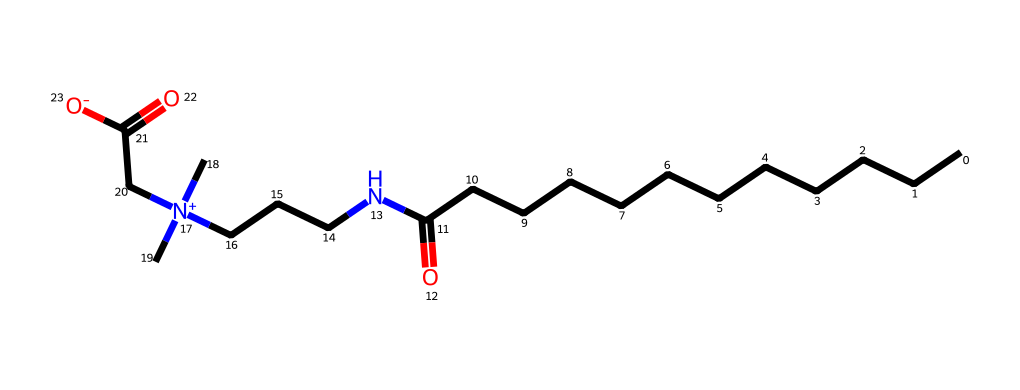What is the chemical name of this compound? The SMILES notation indicates a specific molecular structure, which corresponds to cocamidopropyl betaine, a well-known amphoteric surfactant.
Answer: cocamidopropyl betaine How many carbon atoms are present in this molecule? The SMILES shows a sequence of "C" symbols representing carbon atoms, and by counting, there are 14 carbon atoms in the main chain and additional terminal groups.
Answer: 14 What type of surfactant is cocamidopropyl betaine? The presence of both cationic and anionic groups in the structure classifies cocamidopropyl betaine as an amphoteric surfactant.
Answer: amphoteric How many nitrogen atoms are in cocamidopropyl betaine? The SMILES reveals two "N" symbols, indicating the presence of two nitrogen atoms in the molecule.
Answer: 2 What is the significance of the quaternary ammonium group in the structure? The quaternary ammonium group, indicated by [N+](C)(C), contributes to the surfactant's positive charge, enhancing its ability to interact with various substances, making it effective in personal care formulations.
Answer: positive charge How many oxygen atoms are present in the molecule? The molecule contains two oxygen atoms, as seen in the functional groups where O is listed in the SMILES. Counting these reveals two distinct oxygen contributions.
Answer: 2 What property does the long carbon chain provide to cocamidopropyl betaine? The long carbon chain contributes hydrophobic characteristics, which helps the surfactant reduce surface tension and improve the wetting properties in the formulation.
Answer: hydrophobicity 